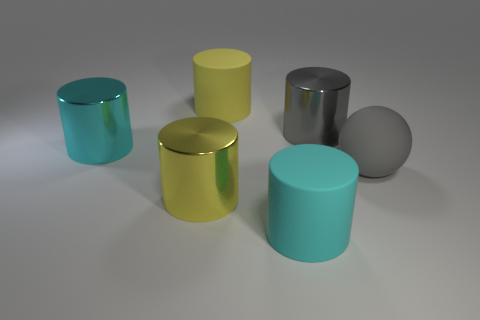What is the size of the yellow shiny object that is the same shape as the gray shiny object?
Your answer should be compact. Large. How big is the cylinder that is in front of the cyan shiny thing and on the right side of the yellow rubber cylinder?
Your response must be concise. Large. Are there any big gray cylinders in front of the large gray matte object?
Provide a short and direct response. No. What number of objects are things that are behind the big gray metallic object or green metal cylinders?
Your response must be concise. 1. How many big cyan matte cylinders are left of the yellow object in front of the big yellow matte cylinder?
Your answer should be very brief. 0. Are there fewer cyan metallic things that are on the right side of the big gray matte sphere than yellow shiny cylinders that are on the right side of the big cyan rubber cylinder?
Provide a short and direct response. No. What is the shape of the large yellow object that is in front of the large yellow object behind the gray matte object?
Offer a very short reply. Cylinder. How many other objects are there of the same material as the big gray ball?
Offer a very short reply. 2. Is there anything else that has the same size as the cyan metal cylinder?
Keep it short and to the point. Yes. Are there more gray matte spheres than cyan shiny spheres?
Offer a terse response. Yes. 